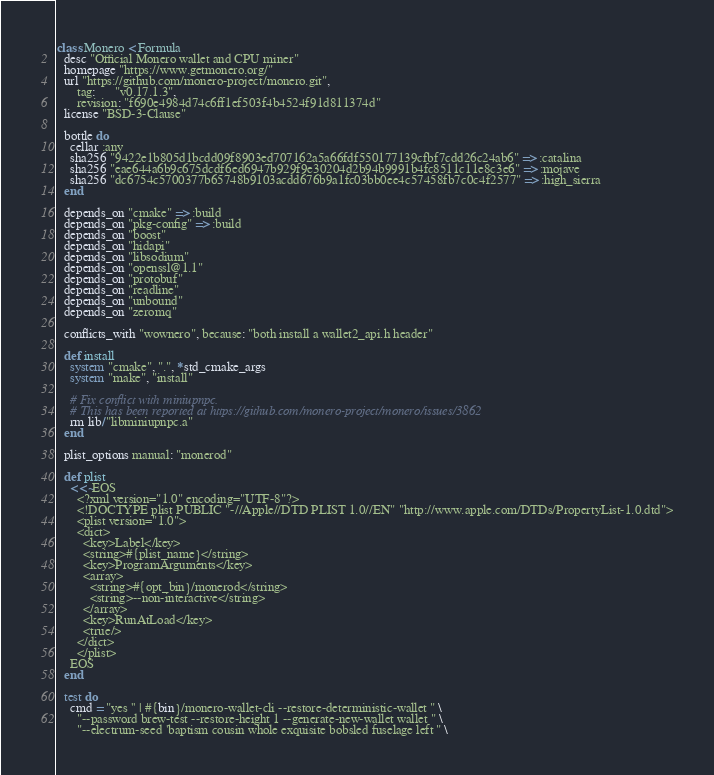<code> <loc_0><loc_0><loc_500><loc_500><_Ruby_>class Monero < Formula
  desc "Official Monero wallet and CPU miner"
  homepage "https://www.getmonero.org/"
  url "https://github.com/monero-project/monero.git",
      tag:      "v0.17.1.3",
      revision: "f690e4984d74c6ff1ef503f4b4524f91d811374d"
  license "BSD-3-Clause"

  bottle do
    cellar :any
    sha256 "9422e1b805d1bcdd09f8903ed707162a5a66fdf550177139cfbf7cdd26c24ab6" => :catalina
    sha256 "eae644a6b9c675dcdf6ed6947b929f9e30204d2b94b9991b4fc8511c11e8c3e6" => :mojave
    sha256 "dc6754c5700377b65748b9103acdd676b9a1fc03bb0ee4c57458fb7c0c4f2577" => :high_sierra
  end

  depends_on "cmake" => :build
  depends_on "pkg-config" => :build
  depends_on "boost"
  depends_on "hidapi"
  depends_on "libsodium"
  depends_on "openssl@1.1"
  depends_on "protobuf"
  depends_on "readline"
  depends_on "unbound"
  depends_on "zeromq"

  conflicts_with "wownero", because: "both install a wallet2_api.h header"

  def install
    system "cmake", ".", *std_cmake_args
    system "make", "install"

    # Fix conflict with miniupnpc.
    # This has been reported at https://github.com/monero-project/monero/issues/3862
    rm lib/"libminiupnpc.a"
  end

  plist_options manual: "monerod"

  def plist
    <<~EOS
      <?xml version="1.0" encoding="UTF-8"?>
      <!DOCTYPE plist PUBLIC "-//Apple//DTD PLIST 1.0//EN" "http://www.apple.com/DTDs/PropertyList-1.0.dtd">
      <plist version="1.0">
      <dict>
        <key>Label</key>
        <string>#{plist_name}</string>
        <key>ProgramArguments</key>
        <array>
          <string>#{opt_bin}/monerod</string>
          <string>--non-interactive</string>
        </array>
        <key>RunAtLoad</key>
        <true/>
      </dict>
      </plist>
    EOS
  end

  test do
    cmd = "yes '' | #{bin}/monero-wallet-cli --restore-deterministic-wallet " \
      "--password brew-test --restore-height 1 --generate-new-wallet wallet " \
      "--electrum-seed 'baptism cousin whole exquisite bobsled fuselage left " \</code> 